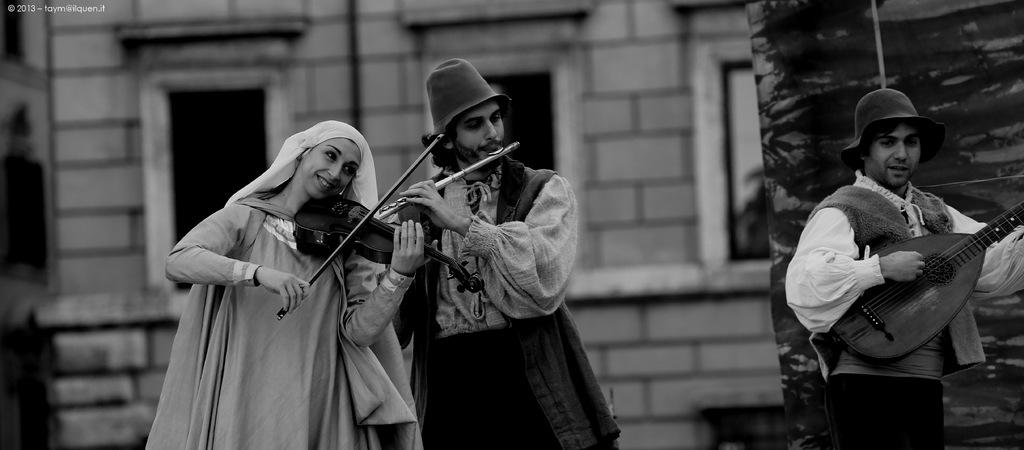Who or what can be seen in the image? There are people in the image. What are the people doing in the image? The people are standing and holding musical instruments in their hands. What is the color scheme of the image? The image is in black and white color. Can you see the moon in the image? There is no moon visible in the image; it features people standing and holding musical instruments. What type of wristwatch is the person wearing in the image? There is no wristwatch present in the image, as it is in black and white color and wristwatches are typically not visible in such images. 